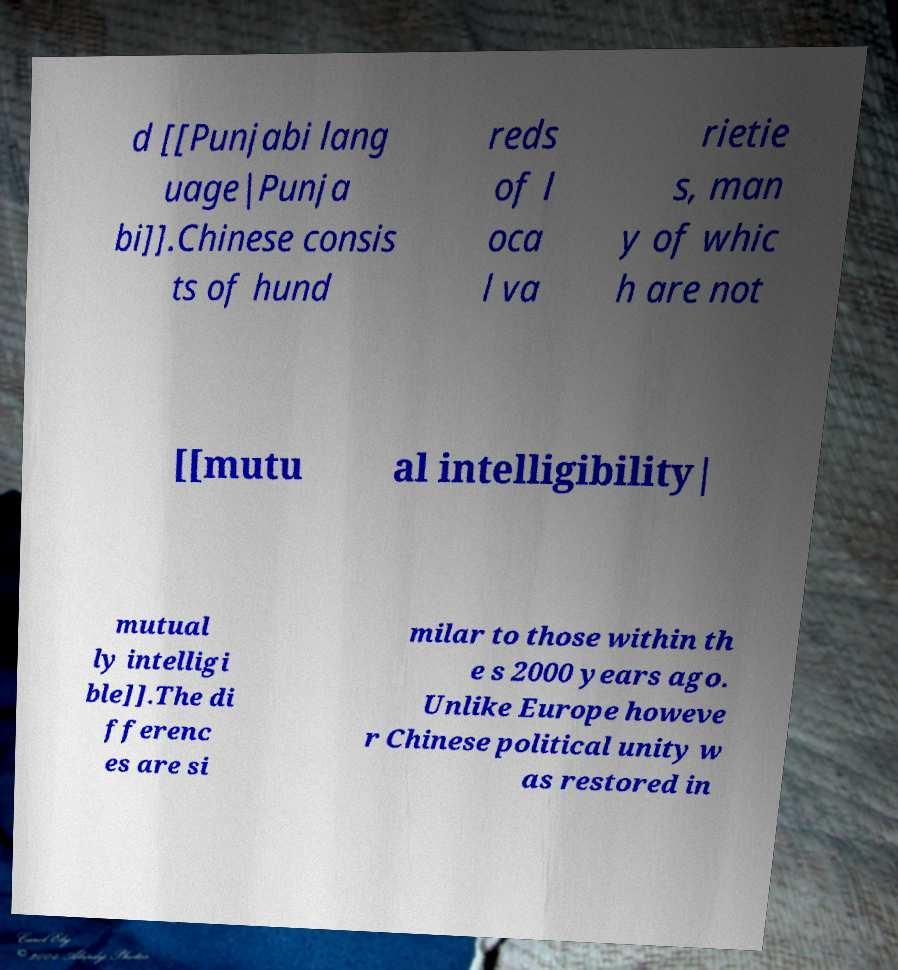Please identify and transcribe the text found in this image. d [[Punjabi lang uage|Punja bi]].Chinese consis ts of hund reds of l oca l va rietie s, man y of whic h are not [[mutu al intelligibility| mutual ly intelligi ble]].The di fferenc es are si milar to those within th e s 2000 years ago. Unlike Europe howeve r Chinese political unity w as restored in 